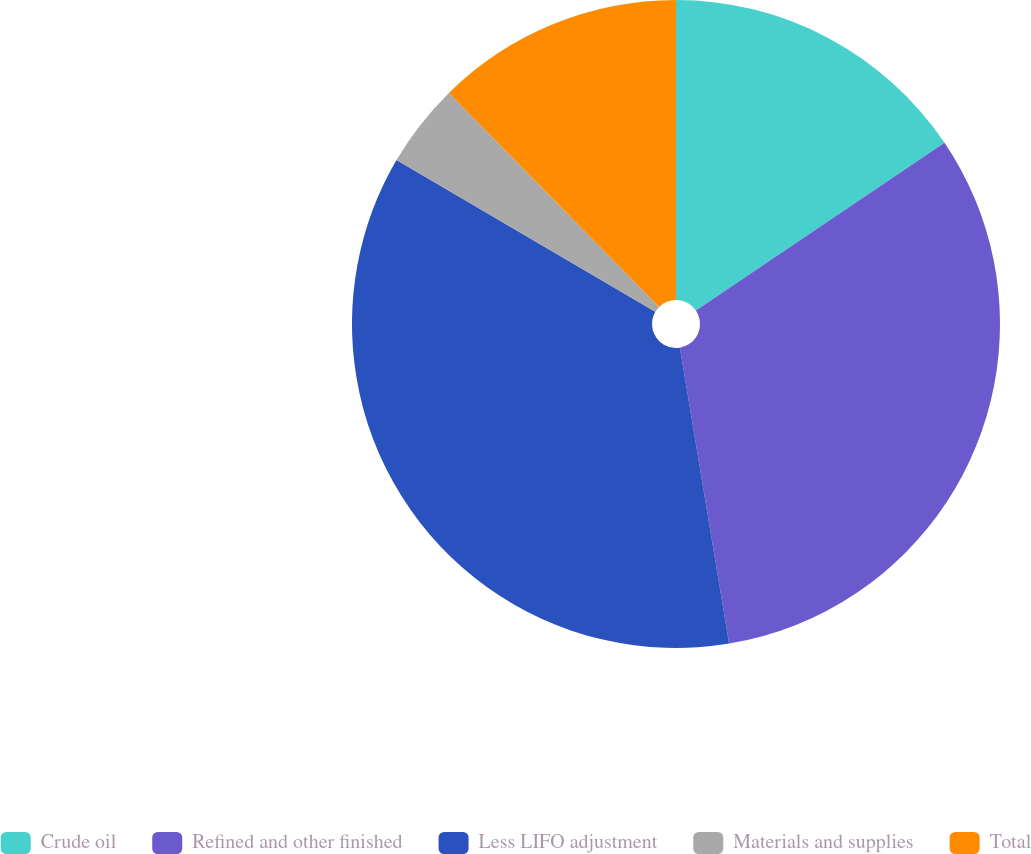Convert chart to OTSL. <chart><loc_0><loc_0><loc_500><loc_500><pie_chart><fcel>Crude oil<fcel>Refined and other finished<fcel>Less LIFO adjustment<fcel>Materials and supplies<fcel>Total<nl><fcel>15.55%<fcel>31.83%<fcel>36.06%<fcel>4.2%<fcel>12.36%<nl></chart> 